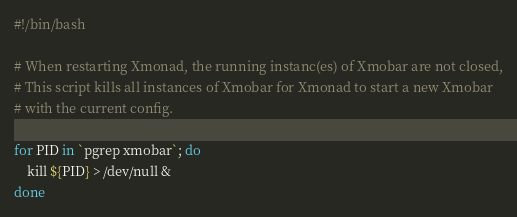<code> <loc_0><loc_0><loc_500><loc_500><_Bash_>#!/bin/bash

# When restarting Xmonad, the running instanc(es) of Xmobar are not closed,
# This script kills all instances of Xmobar for Xmonad to start a new Xmobar
# with the current config.

for PID in `pgrep xmobar`; do
    kill ${PID} > /dev/null &
done
</code> 